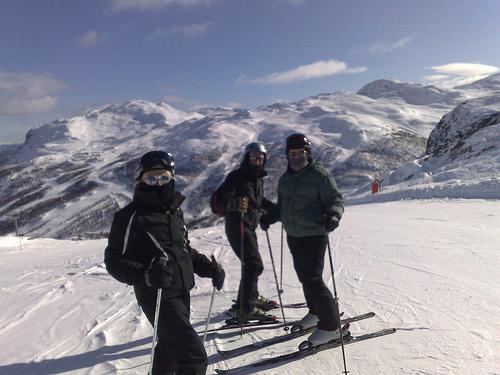Question: what sport is depicted?
Choices:
A. Skiing.
B. Surfing.
C. Skateboarding.
D. Biking.
Answer with the letter. Answer: A Question: what is on top of every skiers head?
Choices:
A. Hat.
B. Helmet.
C. Goggles.
D. Earmuffs.
Answer with the letter. Answer: B Question: why is the ground white?
Choices:
A. Snow.
B. Salt.
C. Paint.
D. Concrete color.
Answer with the letter. Answer: A Question: where is the photo taken?
Choices:
A. Beach.
B. Desert.
C. Mountains.
D. Forest.
Answer with the letter. Answer: C Question: how many skiers are shown?
Choices:
A. Three.
B. Four.
C. Five.
D. Eight.
Answer with the letter. Answer: A Question: how many poles does each skier hold?
Choices:
A. One.
B. Zero.
C. Three.
D. Two.
Answer with the letter. Answer: D Question: when was the photo taken?
Choices:
A. Winter.
B. Spring.
C. Summer.
D. Fall.
Answer with the letter. Answer: A 